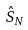Convert formula to latex. <formula><loc_0><loc_0><loc_500><loc_500>\hat { S } _ { N }</formula> 